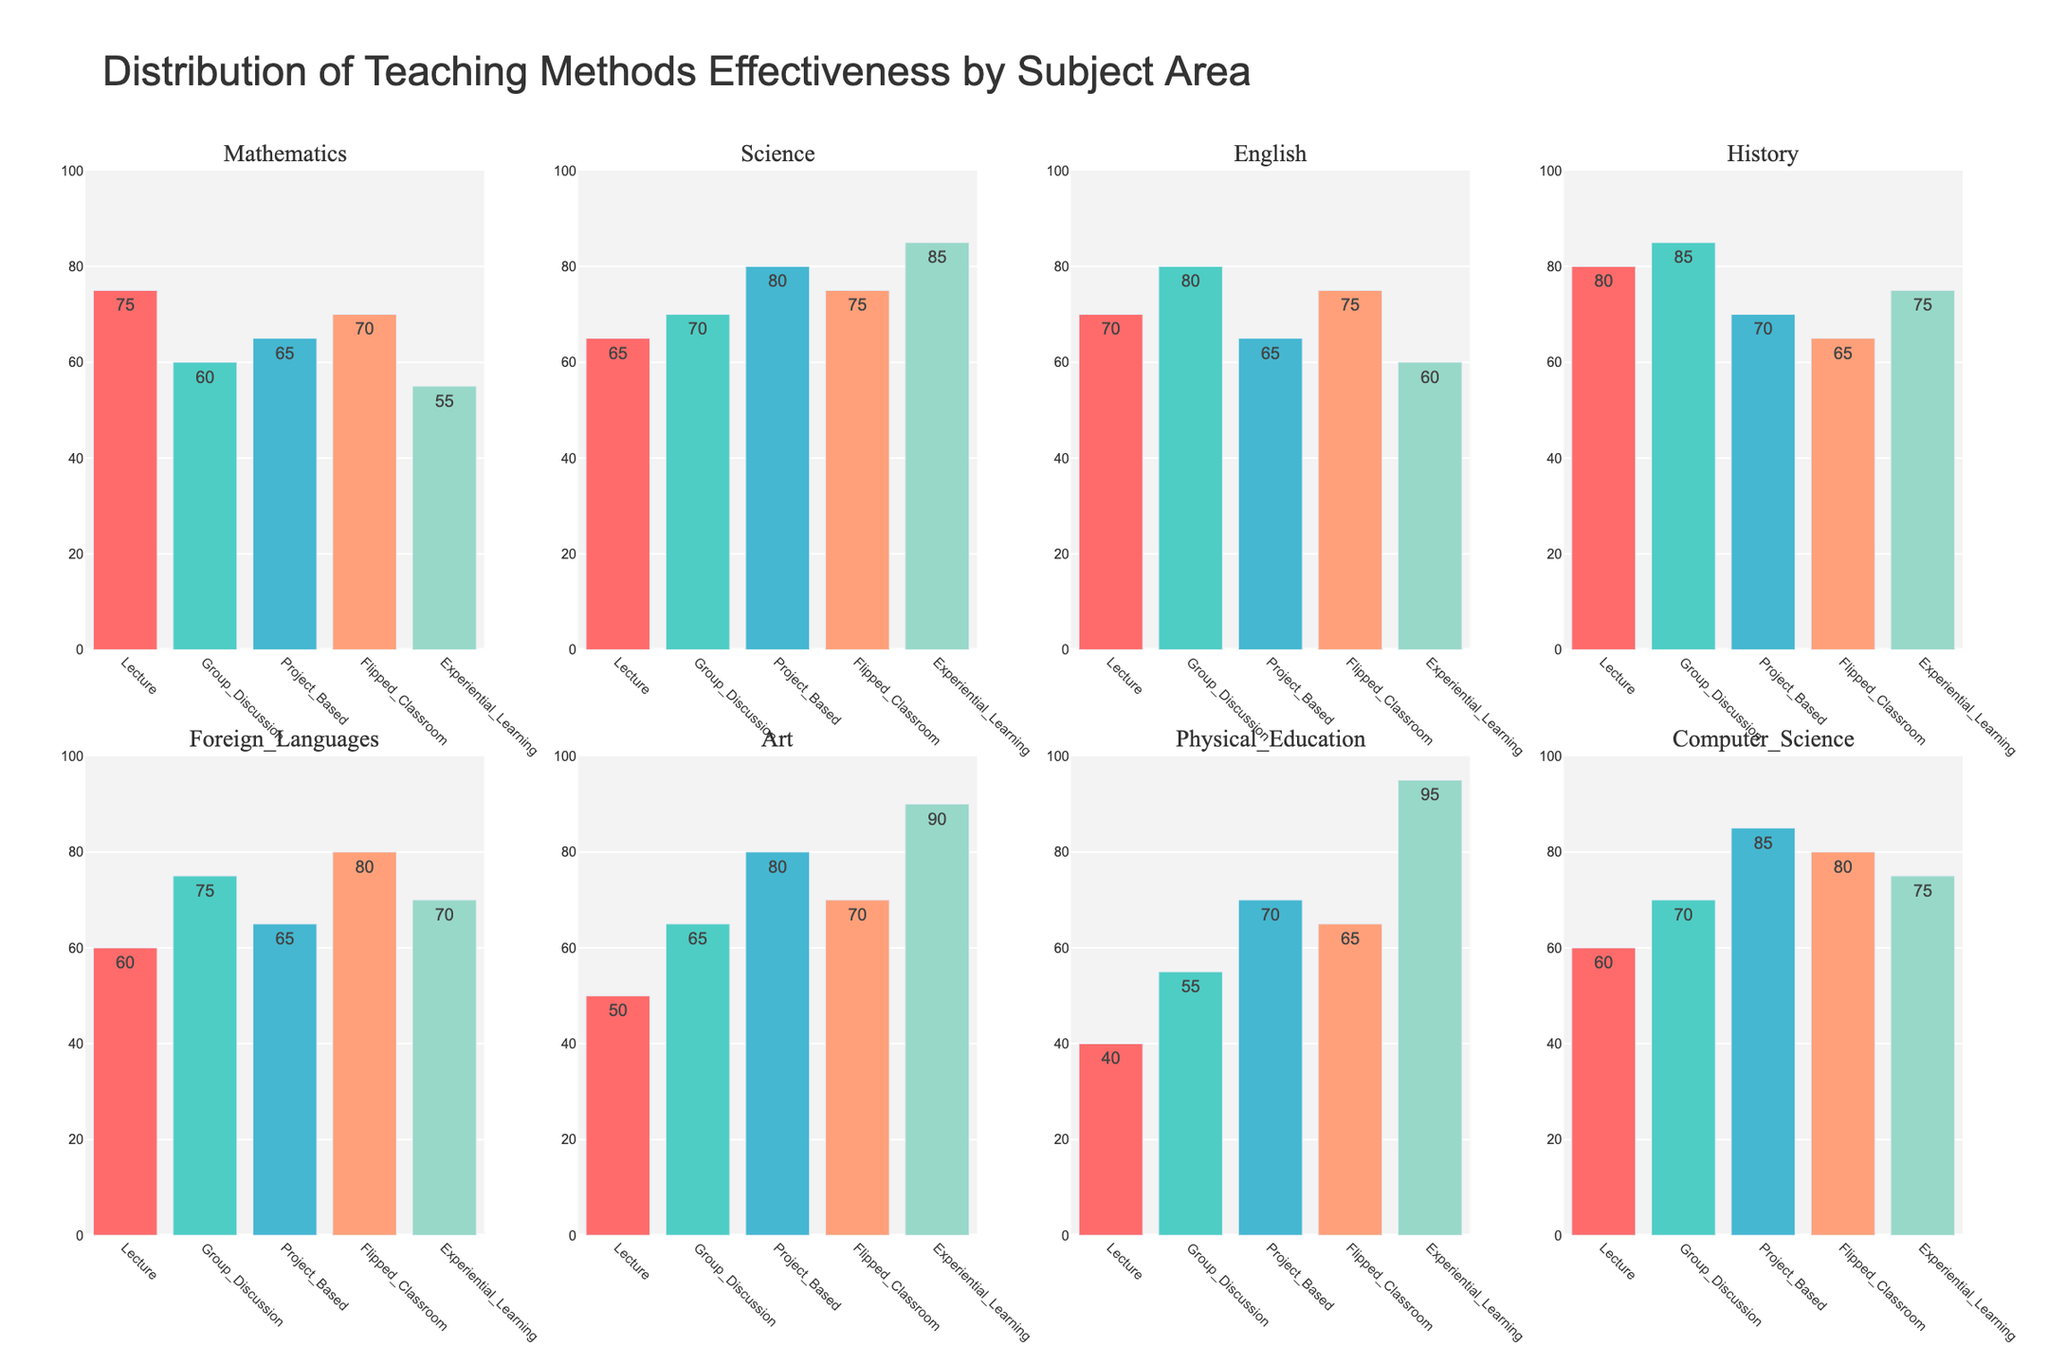What is the title of the figure? The title of the figure is displayed prominently at the top of the visualization. It is used to provide a brief description of what the data represents.
Answer: Distribution of Teaching Methods Effectiveness by Subject Area Which subject shows the highest effectiveness for Group Discussion? By looking at the bar with the highest value in the Group Discussion sections across all subplots, we can determine which subject has the highest effectiveness.
Answer: History What is the average effectiveness score of Lecture and Project Based methods for Mathematics? First, identify the scores for Lecture and Project Based methods in Mathematics, which are 75 and 65. Then, calculate the average: (75 + 65) / 2 = 70.
Answer: 70 Which teaching method has the lowest effectiveness for Physical Education? By finding the shortest bar in the Physical Education subplot, we can identify which teaching method has the lowest effectiveness score.
Answer: Lecture Does Science have a higher effectiveness score for Project Based or Flipped Classroom? Compare the heights of the bars for Project Based (80) and Flipped Classroom (75) methods in the Science subplot.
Answer: Project Based Which teaching method has the highest average effectiveness score across all subjects? Calculate the average effectiveness score for each method across all subjects. Experiential Learning has the highest average score, given its generally high values across subjects.
Answer: Experiential Learning In which subject is the difference between the most and least effective teaching methods the greatest? For each subject, subtract the lowest effectiveness score from the highest. Experiential Learning in Physical Education and Art both show significant differences. Here, we see for Physical Education: 95 (Experiential Learning) - 40 (Lecture) = 55.
Answer: Physical Education Which subject has the smallest variation in effectiveness between different teaching methods? Calculate the range (difference between the highest and lowest values) for each subject. The smallest range will have the least variation in effectiveness.
Answer: Mathematics Which two teaching methods have the closest effectiveness scores in Art? Look at the bars for Art and identify two bars that are closest in height to each other. Project Based (80) and Flipped Classroom (70) have a difference of 10.
Answer: Flipped Classroom and Lecture 